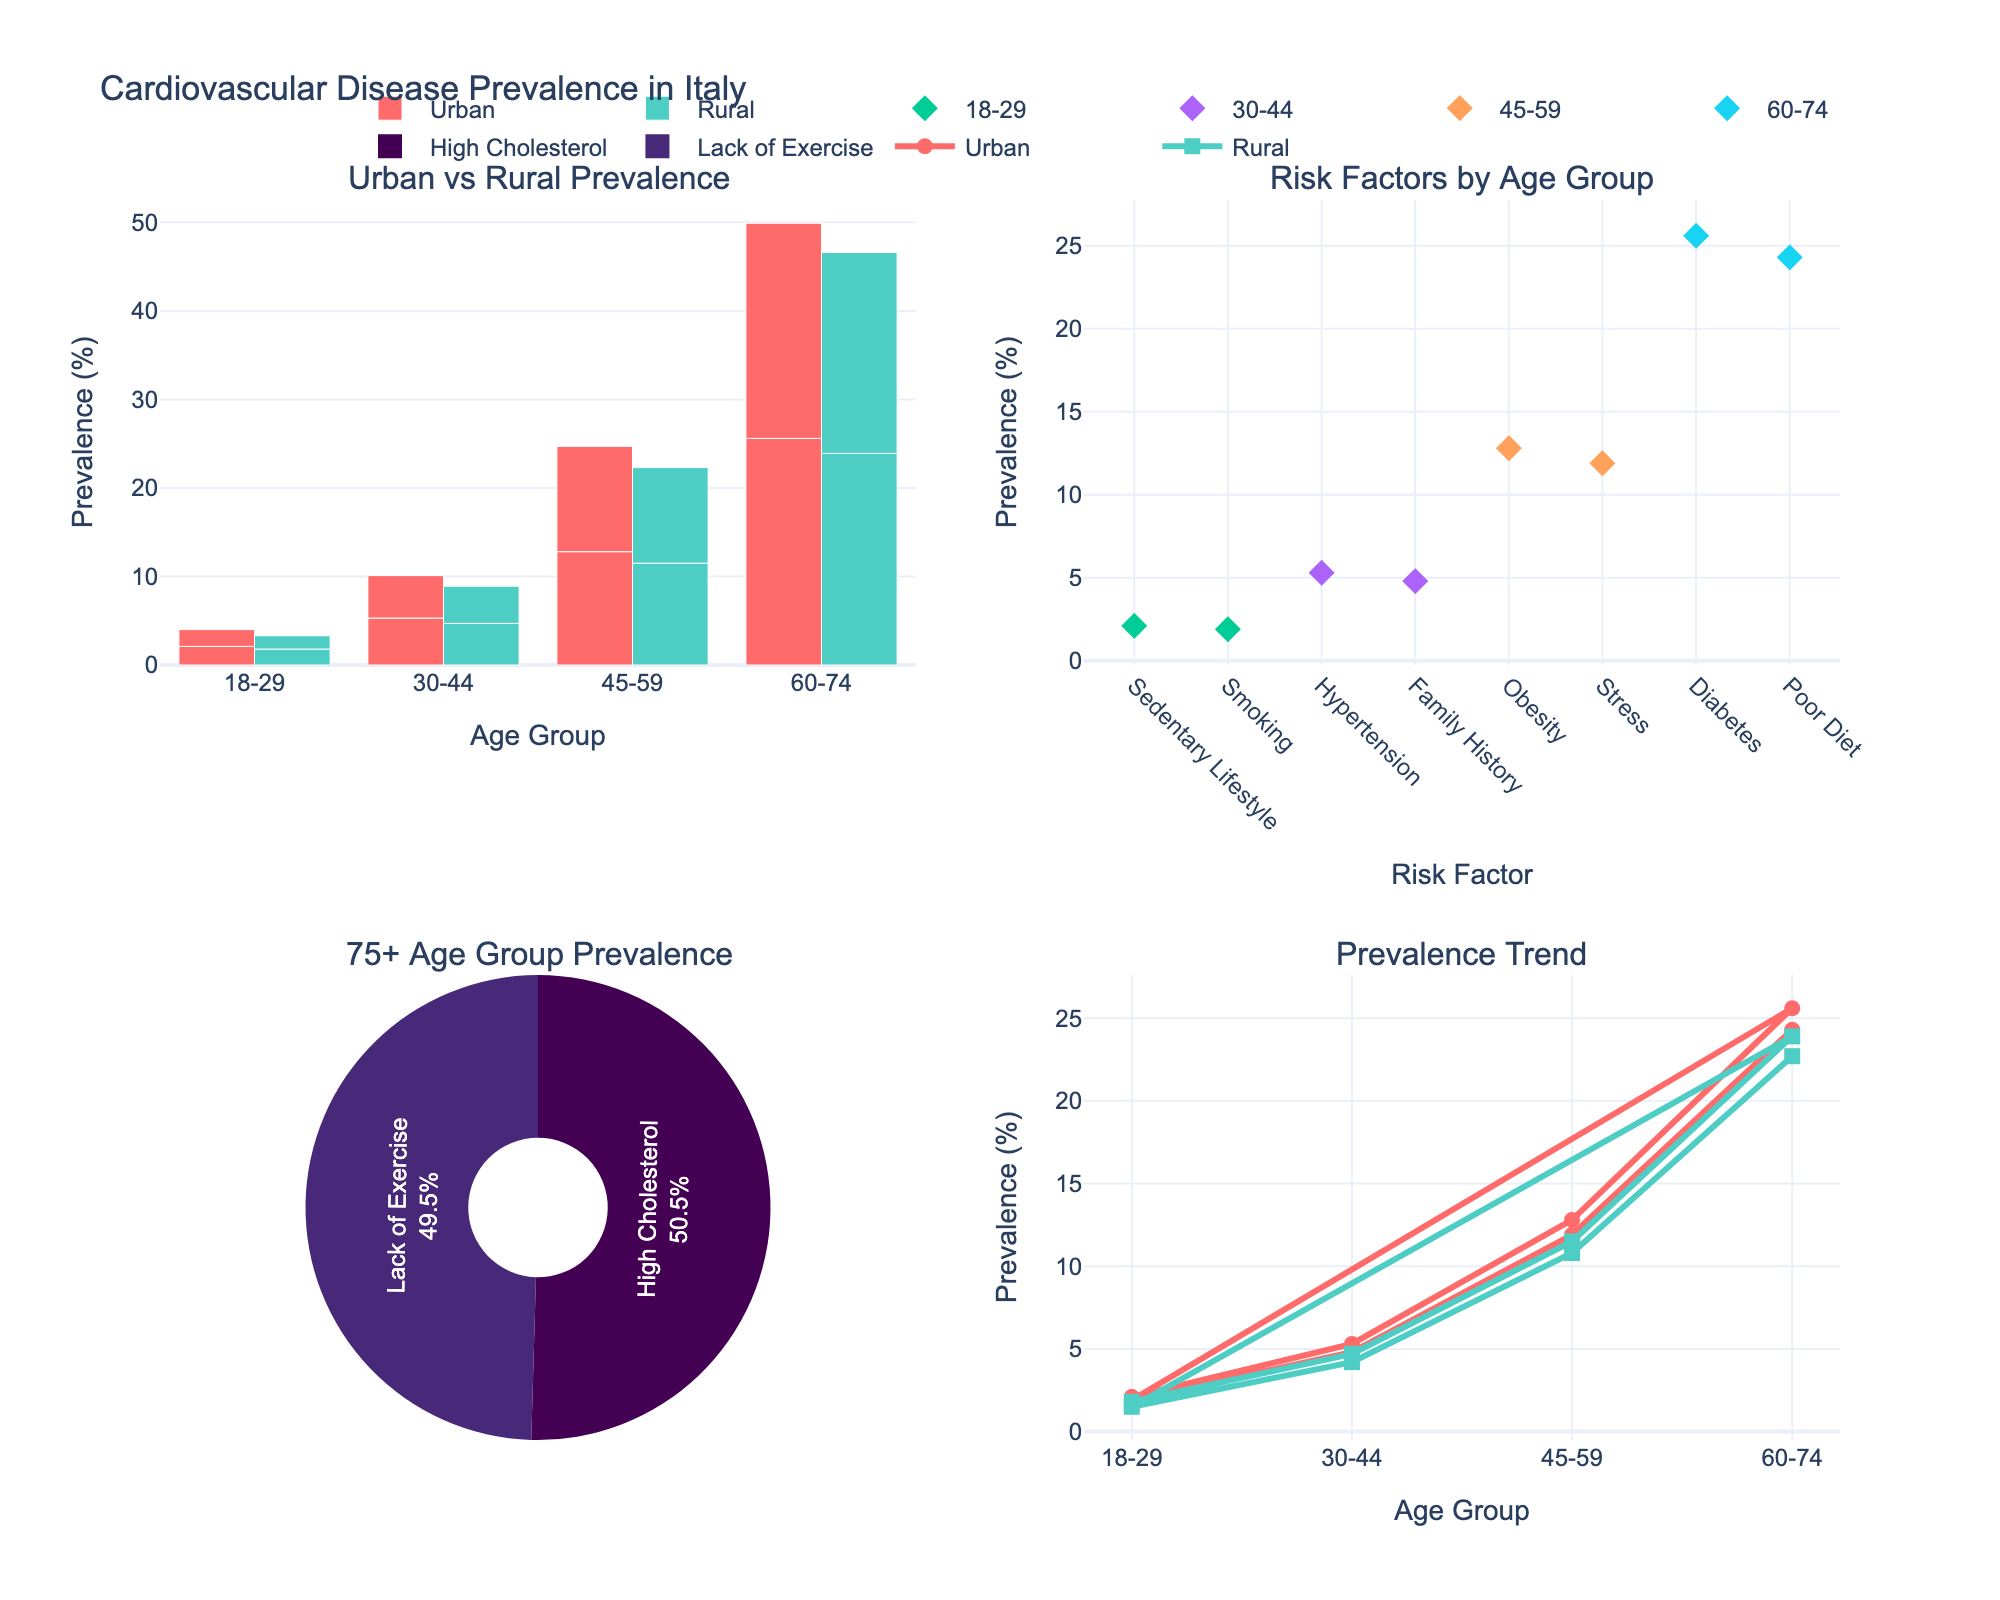What's the title of the figure? The title of the figure is located at the top and provides a summary of the content. It reads "Cardiovascular Disease Prevalence in Italy".
Answer: Cardiovascular Disease Prevalence in Italy Which age group has the highest urban prevalence in the bar chart? To find the highest urban prevalence, refer to the bar chart on the top left. The tallest bar for the urban area corresponds to the age group "75+".
Answer: 75+ What is the difference in prevalence between urban and rural areas for the 45-59 age group in the bar chart? First, locate the bars for the 45-59 age group. The urban bar shows 12.8% and the rural bar shows 11.5%. Calculate the difference: 12.8 - 11.5.
Answer: 1.3% Which age group has the highest rural prevalence according to the line chart? Refer to the line chart on the bottom right. The highest rural prevalence line corresponds to the 75+ age group based on the peak point on the graph.
Answer: 75+ What risk factor is associated with the lowest urban prevalence in the scatter plot? Look at the scatter plot on the top right. The marker with the lowest urban prevalence corresponds to the "Smoking" risk factor.
Answer: Smoking Which age group is most represented in the pie chart for the 75+ age group prevalence? The pie chart on the bottom left shows different risk factors. The largest segment of the pie chart, which represents the highest prevalence, is associated with the "High Cholesterol" risk factor.
Answer: High Cholesterol Compare the prevalence trend for urban and rural areas between ages 60-74 in the line chart. Are they increasing or decreasing? Refer to the line chart on the bottom right. Both lines for urban and rural areas are increasing as the age group goes from 60-74.
Answer: Increasing How does the prevalence of “Hypertension” compare between urban and rural areas for the 30-44 age group in the scatter plot? Locate the scatter plot points for the 30-44 age group. The "Hypertension” point shows a higher urban prevalence than rural prevalence.
Answer: Higher in Urban By how much does the prevalence of cardiovascular disease increase from the 18-29 age group to the 60-74 age group in urban areas based on the bar chart? Refer to the bars for the 18-29 (2.1%) and 60-74 (25.6%) age groups. Calculate the increase: 25.6 - 2.1.
Answer: 23.5% From the pie chart, what percentage of urban prevalence in the 75+ age group is due to "Lack of Exercise"? Look at the pie chart's segment for "Lack of Exercise". It includes the percentage information next to the label. According to the text, it represents a certain proportion of the whole.
Answer: Given visually (depends on pie chart's segment label) 